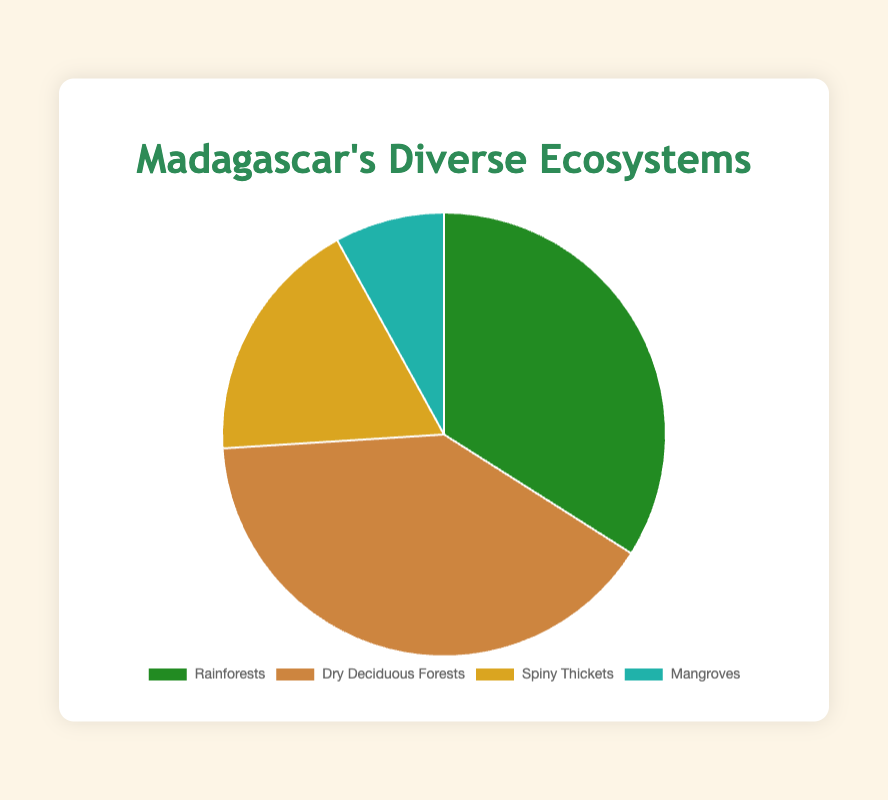What proportion of Madagascar's ecosystems is made up of Rainforests? The chart shows that Rainforests represent 34% of Madagascar's ecosystems.
Answer: 34% Which ecosystem type occupies the largest proportion? By analyzing the sizes of the pie segments, Dry Deciduous Forests occupy the largest portion at 40%.
Answer: Dry Deciduous Forests What is the combined percentage of Rainforests and Spiny Thickets? Adding the percentages for Rainforests (34%) and Spiny Thickets (18%), the total is 34% + 18% = 52%.
Answer: 52% How much larger is the proportion of Dry Deciduous Forests compared to Mangroves? The proportion of Dry Deciduous Forests is 40% and Mangroves is 8%. The difference is 40% - 8% = 32%.
Answer: 32% What ecosystem has the smallest proportion and what is that proportion? The segment representing Mangroves is the smallest, occupying 8% of the chart.
Answer: Mangroves, 8% How do the proportions of Spiny Thickets and Mangroves compare? The chart shows Spiny Thickets at 18% and Mangroves at 8%. Spiny Thickets have a higher proportion by 18% - 8% = 10%.
Answer: Spiny Thickets have 10% more What proportion of Madagascar's ecosystems is made up of terrestrial ecosystems (Rainforests, Dry Deciduous Forests, and Spiny Thickets)? Adding the percentages for Rainforests (34%), Dry Deciduous Forests (40%), and Spiny Thickets (18%), the total is 34% + 40% + 18% = 92%.
Answer: 92% Which ecosystem occupies a larger proportion, Rainforests or Spiny Thickets? Comparing 34% for Rainforests and 18% for Spiny Thickets, Rainforests have a larger proportion.
Answer: Rainforests What color is used to represent the Mangroves in the pie chart? Observing the pie chart, Mangroves are represented by a light sea green color.
Answer: Light sea green What is the average percentage of all four ecosystem types? Adding up all percentages: 34% + 40% + 18% + 8% = 100%. The average percentage is 100% / 4 = 25%.
Answer: 25% 